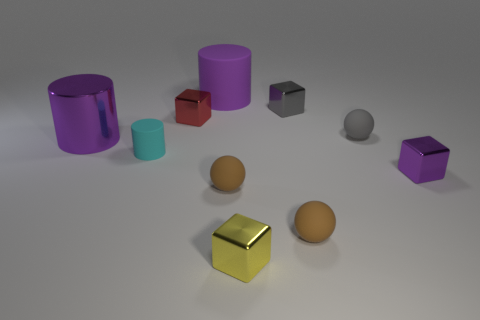Are there any other things that have the same size as the gray sphere?
Keep it short and to the point. Yes. Is the number of tiny gray cubes that are behind the cyan rubber cylinder greater than the number of purple cylinders that are in front of the gray cube?
Your response must be concise. No. There is a block on the left side of the small yellow shiny thing; what is it made of?
Keep it short and to the point. Metal. Do the large purple matte object and the matte thing that is to the left of the purple rubber cylinder have the same shape?
Give a very brief answer. Yes. How many gray matte things are in front of the small ball behind the purple shiny thing in front of the cyan thing?
Your response must be concise. 0. The other rubber object that is the same shape as the purple matte object is what color?
Keep it short and to the point. Cyan. Is there any other thing that is the same shape as the red metallic object?
Provide a short and direct response. Yes. What number of spheres are either big purple metallic things or small red metallic objects?
Provide a succinct answer. 0. The purple rubber thing has what shape?
Keep it short and to the point. Cylinder. There is a tiny gray ball; are there any matte spheres in front of it?
Give a very brief answer. Yes. 